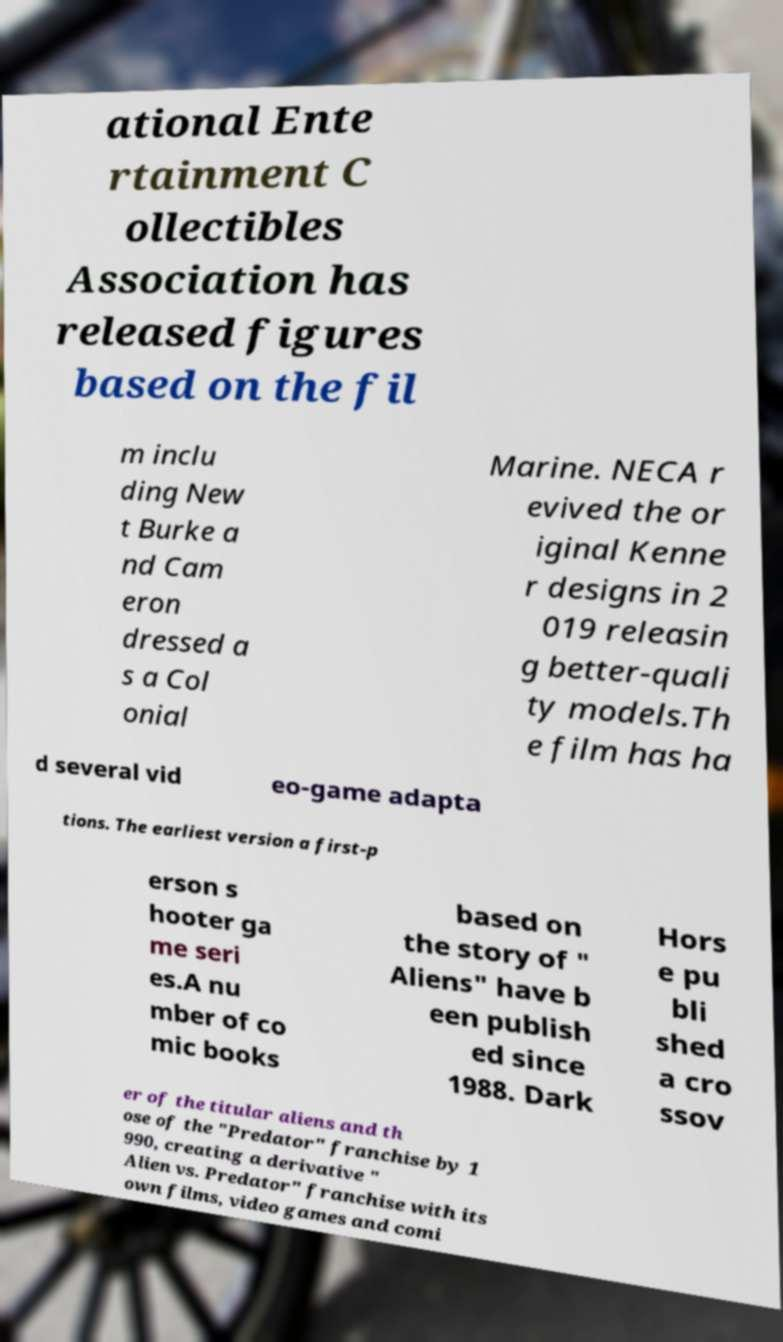Please read and relay the text visible in this image. What does it say? ational Ente rtainment C ollectibles Association has released figures based on the fil m inclu ding New t Burke a nd Cam eron dressed a s a Col onial Marine. NECA r evived the or iginal Kenne r designs in 2 019 releasin g better-quali ty models.Th e film has ha d several vid eo-game adapta tions. The earliest version a first-p erson s hooter ga me seri es.A nu mber of co mic books based on the story of " Aliens" have b een publish ed since 1988. Dark Hors e pu bli shed a cro ssov er of the titular aliens and th ose of the "Predator" franchise by 1 990, creating a derivative " Alien vs. Predator" franchise with its own films, video games and comi 